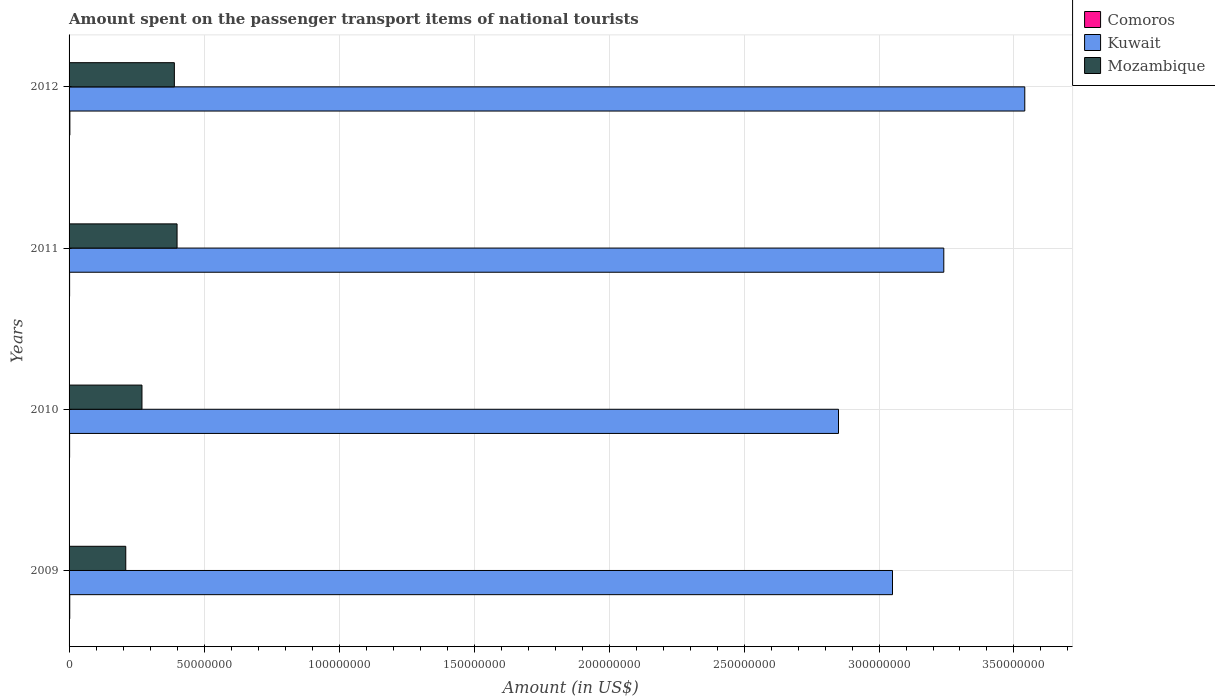Are the number of bars per tick equal to the number of legend labels?
Ensure brevity in your answer.  Yes. Are the number of bars on each tick of the Y-axis equal?
Offer a very short reply. Yes. What is the amount spent on the passenger transport items of national tourists in Kuwait in 2011?
Offer a very short reply. 3.24e+08. Across all years, what is the maximum amount spent on the passenger transport items of national tourists in Kuwait?
Your answer should be very brief. 3.54e+08. In which year was the amount spent on the passenger transport items of national tourists in Comoros maximum?
Ensure brevity in your answer.  2012. In which year was the amount spent on the passenger transport items of national tourists in Comoros minimum?
Your response must be concise. 2010. What is the total amount spent on the passenger transport items of national tourists in Mozambique in the graph?
Provide a succinct answer. 1.27e+08. What is the difference between the amount spent on the passenger transport items of national tourists in Comoros in 2010 and that in 2011?
Ensure brevity in your answer.  0. What is the difference between the amount spent on the passenger transport items of national tourists in Mozambique in 2010 and the amount spent on the passenger transport items of national tourists in Comoros in 2012?
Provide a succinct answer. 2.67e+07. What is the average amount spent on the passenger transport items of national tourists in Comoros per year?
Provide a succinct answer. 2.38e+05. In the year 2009, what is the difference between the amount spent on the passenger transport items of national tourists in Comoros and amount spent on the passenger transport items of national tourists in Kuwait?
Ensure brevity in your answer.  -3.05e+08. In how many years, is the amount spent on the passenger transport items of national tourists in Kuwait greater than 330000000 US$?
Give a very brief answer. 1. What is the ratio of the amount spent on the passenger transport items of national tourists in Kuwait in 2009 to that in 2010?
Your answer should be compact. 1.07. Is the amount spent on the passenger transport items of national tourists in Mozambique in 2009 less than that in 2012?
Provide a short and direct response. Yes. What is the difference between the highest and the second highest amount spent on the passenger transport items of national tourists in Kuwait?
Provide a succinct answer. 3.00e+07. What is the difference between the highest and the lowest amount spent on the passenger transport items of national tourists in Comoros?
Your answer should be very brief. 1.00e+05. What does the 3rd bar from the top in 2012 represents?
Provide a succinct answer. Comoros. What does the 3rd bar from the bottom in 2011 represents?
Provide a succinct answer. Mozambique. What is the difference between two consecutive major ticks on the X-axis?
Provide a succinct answer. 5.00e+07. Are the values on the major ticks of X-axis written in scientific E-notation?
Your answer should be very brief. No. How many legend labels are there?
Make the answer very short. 3. What is the title of the graph?
Ensure brevity in your answer.  Amount spent on the passenger transport items of national tourists. What is the Amount (in US$) of Comoros in 2009?
Provide a short and direct response. 2.50e+05. What is the Amount (in US$) in Kuwait in 2009?
Offer a very short reply. 3.05e+08. What is the Amount (in US$) of Mozambique in 2009?
Offer a terse response. 2.10e+07. What is the Amount (in US$) of Comoros in 2010?
Your answer should be compact. 2.00e+05. What is the Amount (in US$) in Kuwait in 2010?
Provide a short and direct response. 2.85e+08. What is the Amount (in US$) in Mozambique in 2010?
Your answer should be very brief. 2.70e+07. What is the Amount (in US$) in Kuwait in 2011?
Your answer should be compact. 3.24e+08. What is the Amount (in US$) of Mozambique in 2011?
Offer a very short reply. 4.00e+07. What is the Amount (in US$) of Comoros in 2012?
Ensure brevity in your answer.  3.00e+05. What is the Amount (in US$) of Kuwait in 2012?
Provide a succinct answer. 3.54e+08. What is the Amount (in US$) in Mozambique in 2012?
Your answer should be very brief. 3.90e+07. Across all years, what is the maximum Amount (in US$) of Comoros?
Your answer should be compact. 3.00e+05. Across all years, what is the maximum Amount (in US$) in Kuwait?
Provide a short and direct response. 3.54e+08. Across all years, what is the maximum Amount (in US$) of Mozambique?
Provide a succinct answer. 4.00e+07. Across all years, what is the minimum Amount (in US$) of Comoros?
Make the answer very short. 2.00e+05. Across all years, what is the minimum Amount (in US$) of Kuwait?
Give a very brief answer. 2.85e+08. Across all years, what is the minimum Amount (in US$) in Mozambique?
Provide a short and direct response. 2.10e+07. What is the total Amount (in US$) of Comoros in the graph?
Make the answer very short. 9.50e+05. What is the total Amount (in US$) in Kuwait in the graph?
Provide a short and direct response. 1.27e+09. What is the total Amount (in US$) in Mozambique in the graph?
Keep it short and to the point. 1.27e+08. What is the difference between the Amount (in US$) in Mozambique in 2009 and that in 2010?
Give a very brief answer. -6.00e+06. What is the difference between the Amount (in US$) of Kuwait in 2009 and that in 2011?
Your answer should be compact. -1.90e+07. What is the difference between the Amount (in US$) in Mozambique in 2009 and that in 2011?
Your response must be concise. -1.90e+07. What is the difference between the Amount (in US$) in Comoros in 2009 and that in 2012?
Your answer should be very brief. -5.00e+04. What is the difference between the Amount (in US$) in Kuwait in 2009 and that in 2012?
Ensure brevity in your answer.  -4.90e+07. What is the difference between the Amount (in US$) of Mozambique in 2009 and that in 2012?
Your response must be concise. -1.80e+07. What is the difference between the Amount (in US$) of Comoros in 2010 and that in 2011?
Ensure brevity in your answer.  0. What is the difference between the Amount (in US$) of Kuwait in 2010 and that in 2011?
Offer a terse response. -3.90e+07. What is the difference between the Amount (in US$) of Mozambique in 2010 and that in 2011?
Your response must be concise. -1.30e+07. What is the difference between the Amount (in US$) of Comoros in 2010 and that in 2012?
Make the answer very short. -1.00e+05. What is the difference between the Amount (in US$) in Kuwait in 2010 and that in 2012?
Offer a very short reply. -6.90e+07. What is the difference between the Amount (in US$) in Mozambique in 2010 and that in 2012?
Make the answer very short. -1.20e+07. What is the difference between the Amount (in US$) of Kuwait in 2011 and that in 2012?
Offer a very short reply. -3.00e+07. What is the difference between the Amount (in US$) of Mozambique in 2011 and that in 2012?
Offer a terse response. 1.00e+06. What is the difference between the Amount (in US$) in Comoros in 2009 and the Amount (in US$) in Kuwait in 2010?
Your answer should be compact. -2.85e+08. What is the difference between the Amount (in US$) of Comoros in 2009 and the Amount (in US$) of Mozambique in 2010?
Offer a terse response. -2.68e+07. What is the difference between the Amount (in US$) of Kuwait in 2009 and the Amount (in US$) of Mozambique in 2010?
Offer a very short reply. 2.78e+08. What is the difference between the Amount (in US$) in Comoros in 2009 and the Amount (in US$) in Kuwait in 2011?
Your answer should be very brief. -3.24e+08. What is the difference between the Amount (in US$) in Comoros in 2009 and the Amount (in US$) in Mozambique in 2011?
Keep it short and to the point. -3.98e+07. What is the difference between the Amount (in US$) of Kuwait in 2009 and the Amount (in US$) of Mozambique in 2011?
Make the answer very short. 2.65e+08. What is the difference between the Amount (in US$) in Comoros in 2009 and the Amount (in US$) in Kuwait in 2012?
Your answer should be compact. -3.54e+08. What is the difference between the Amount (in US$) in Comoros in 2009 and the Amount (in US$) in Mozambique in 2012?
Your response must be concise. -3.88e+07. What is the difference between the Amount (in US$) of Kuwait in 2009 and the Amount (in US$) of Mozambique in 2012?
Provide a short and direct response. 2.66e+08. What is the difference between the Amount (in US$) of Comoros in 2010 and the Amount (in US$) of Kuwait in 2011?
Your response must be concise. -3.24e+08. What is the difference between the Amount (in US$) in Comoros in 2010 and the Amount (in US$) in Mozambique in 2011?
Your answer should be very brief. -3.98e+07. What is the difference between the Amount (in US$) of Kuwait in 2010 and the Amount (in US$) of Mozambique in 2011?
Provide a short and direct response. 2.45e+08. What is the difference between the Amount (in US$) of Comoros in 2010 and the Amount (in US$) of Kuwait in 2012?
Ensure brevity in your answer.  -3.54e+08. What is the difference between the Amount (in US$) of Comoros in 2010 and the Amount (in US$) of Mozambique in 2012?
Your answer should be compact. -3.88e+07. What is the difference between the Amount (in US$) of Kuwait in 2010 and the Amount (in US$) of Mozambique in 2012?
Provide a short and direct response. 2.46e+08. What is the difference between the Amount (in US$) of Comoros in 2011 and the Amount (in US$) of Kuwait in 2012?
Your answer should be very brief. -3.54e+08. What is the difference between the Amount (in US$) of Comoros in 2011 and the Amount (in US$) of Mozambique in 2012?
Provide a short and direct response. -3.88e+07. What is the difference between the Amount (in US$) in Kuwait in 2011 and the Amount (in US$) in Mozambique in 2012?
Give a very brief answer. 2.85e+08. What is the average Amount (in US$) in Comoros per year?
Ensure brevity in your answer.  2.38e+05. What is the average Amount (in US$) of Kuwait per year?
Make the answer very short. 3.17e+08. What is the average Amount (in US$) in Mozambique per year?
Ensure brevity in your answer.  3.18e+07. In the year 2009, what is the difference between the Amount (in US$) in Comoros and Amount (in US$) in Kuwait?
Provide a succinct answer. -3.05e+08. In the year 2009, what is the difference between the Amount (in US$) in Comoros and Amount (in US$) in Mozambique?
Provide a short and direct response. -2.08e+07. In the year 2009, what is the difference between the Amount (in US$) in Kuwait and Amount (in US$) in Mozambique?
Provide a short and direct response. 2.84e+08. In the year 2010, what is the difference between the Amount (in US$) in Comoros and Amount (in US$) in Kuwait?
Ensure brevity in your answer.  -2.85e+08. In the year 2010, what is the difference between the Amount (in US$) of Comoros and Amount (in US$) of Mozambique?
Make the answer very short. -2.68e+07. In the year 2010, what is the difference between the Amount (in US$) of Kuwait and Amount (in US$) of Mozambique?
Provide a succinct answer. 2.58e+08. In the year 2011, what is the difference between the Amount (in US$) in Comoros and Amount (in US$) in Kuwait?
Your response must be concise. -3.24e+08. In the year 2011, what is the difference between the Amount (in US$) of Comoros and Amount (in US$) of Mozambique?
Your answer should be compact. -3.98e+07. In the year 2011, what is the difference between the Amount (in US$) of Kuwait and Amount (in US$) of Mozambique?
Provide a short and direct response. 2.84e+08. In the year 2012, what is the difference between the Amount (in US$) of Comoros and Amount (in US$) of Kuwait?
Offer a very short reply. -3.54e+08. In the year 2012, what is the difference between the Amount (in US$) in Comoros and Amount (in US$) in Mozambique?
Keep it short and to the point. -3.87e+07. In the year 2012, what is the difference between the Amount (in US$) in Kuwait and Amount (in US$) in Mozambique?
Offer a terse response. 3.15e+08. What is the ratio of the Amount (in US$) of Comoros in 2009 to that in 2010?
Make the answer very short. 1.25. What is the ratio of the Amount (in US$) in Kuwait in 2009 to that in 2010?
Offer a very short reply. 1.07. What is the ratio of the Amount (in US$) in Comoros in 2009 to that in 2011?
Provide a succinct answer. 1.25. What is the ratio of the Amount (in US$) of Kuwait in 2009 to that in 2011?
Give a very brief answer. 0.94. What is the ratio of the Amount (in US$) of Mozambique in 2009 to that in 2011?
Offer a terse response. 0.53. What is the ratio of the Amount (in US$) in Kuwait in 2009 to that in 2012?
Offer a very short reply. 0.86. What is the ratio of the Amount (in US$) in Mozambique in 2009 to that in 2012?
Give a very brief answer. 0.54. What is the ratio of the Amount (in US$) of Kuwait in 2010 to that in 2011?
Give a very brief answer. 0.88. What is the ratio of the Amount (in US$) in Mozambique in 2010 to that in 2011?
Make the answer very short. 0.68. What is the ratio of the Amount (in US$) of Kuwait in 2010 to that in 2012?
Offer a terse response. 0.81. What is the ratio of the Amount (in US$) in Mozambique in 2010 to that in 2012?
Your answer should be compact. 0.69. What is the ratio of the Amount (in US$) in Kuwait in 2011 to that in 2012?
Your answer should be very brief. 0.92. What is the ratio of the Amount (in US$) of Mozambique in 2011 to that in 2012?
Offer a terse response. 1.03. What is the difference between the highest and the second highest Amount (in US$) in Kuwait?
Give a very brief answer. 3.00e+07. What is the difference between the highest and the second highest Amount (in US$) in Mozambique?
Keep it short and to the point. 1.00e+06. What is the difference between the highest and the lowest Amount (in US$) in Kuwait?
Your answer should be compact. 6.90e+07. What is the difference between the highest and the lowest Amount (in US$) of Mozambique?
Make the answer very short. 1.90e+07. 